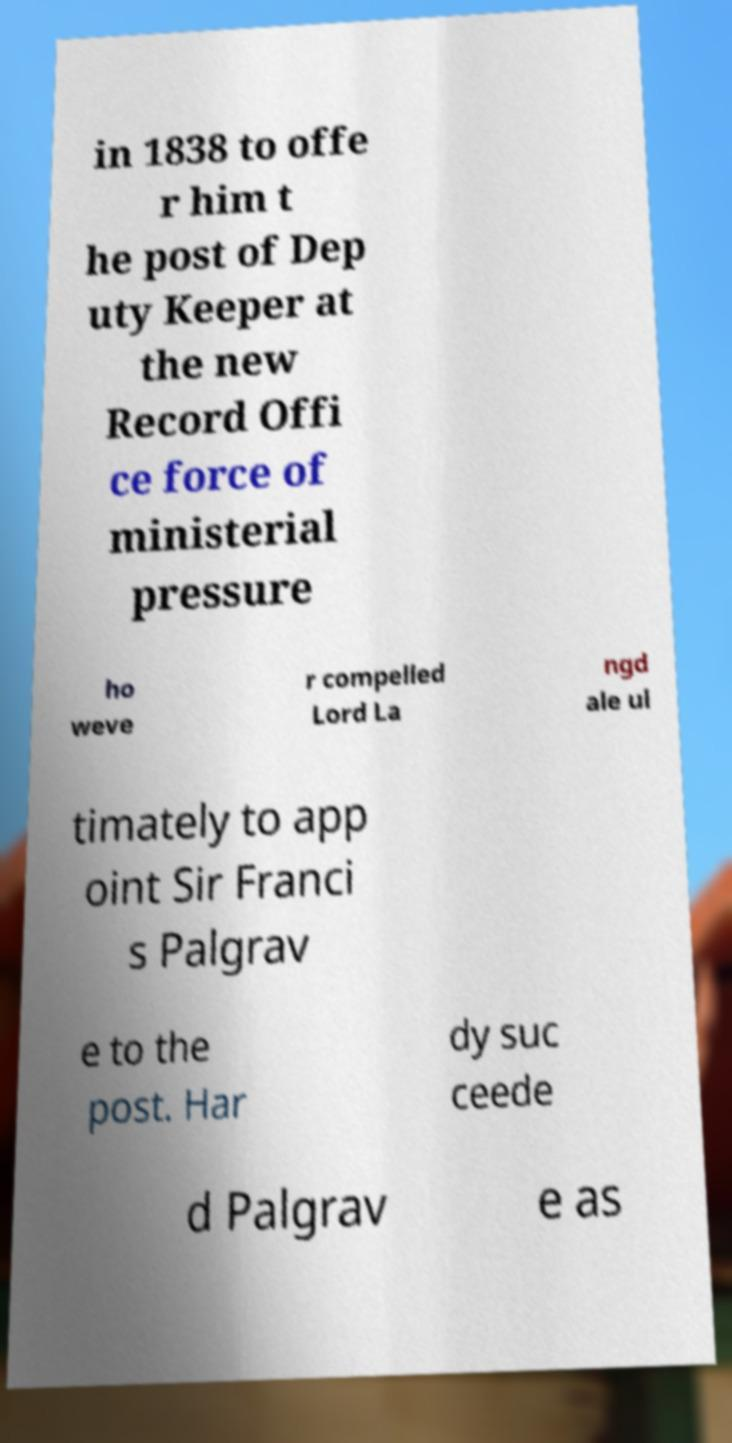For documentation purposes, I need the text within this image transcribed. Could you provide that? in 1838 to offe r him t he post of Dep uty Keeper at the new Record Offi ce force of ministerial pressure ho weve r compelled Lord La ngd ale ul timately to app oint Sir Franci s Palgrav e to the post. Har dy suc ceede d Palgrav e as 